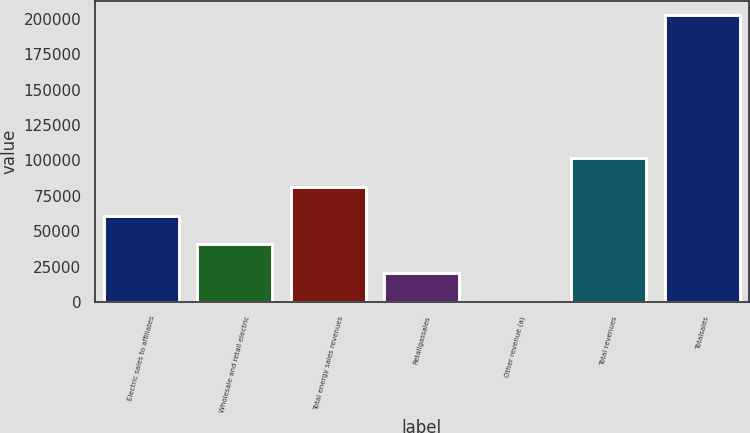<chart> <loc_0><loc_0><loc_500><loc_500><bar_chart><fcel>Electric sales to affiliates<fcel>Wholesale and retail electric<fcel>Total energy sales revenues<fcel>Retailgassales<fcel>Other revenue (a)<fcel>Total revenues<fcel>Totalsales<nl><fcel>60975<fcel>40743<fcel>81207<fcel>20511<fcel>279<fcel>101439<fcel>202599<nl></chart> 